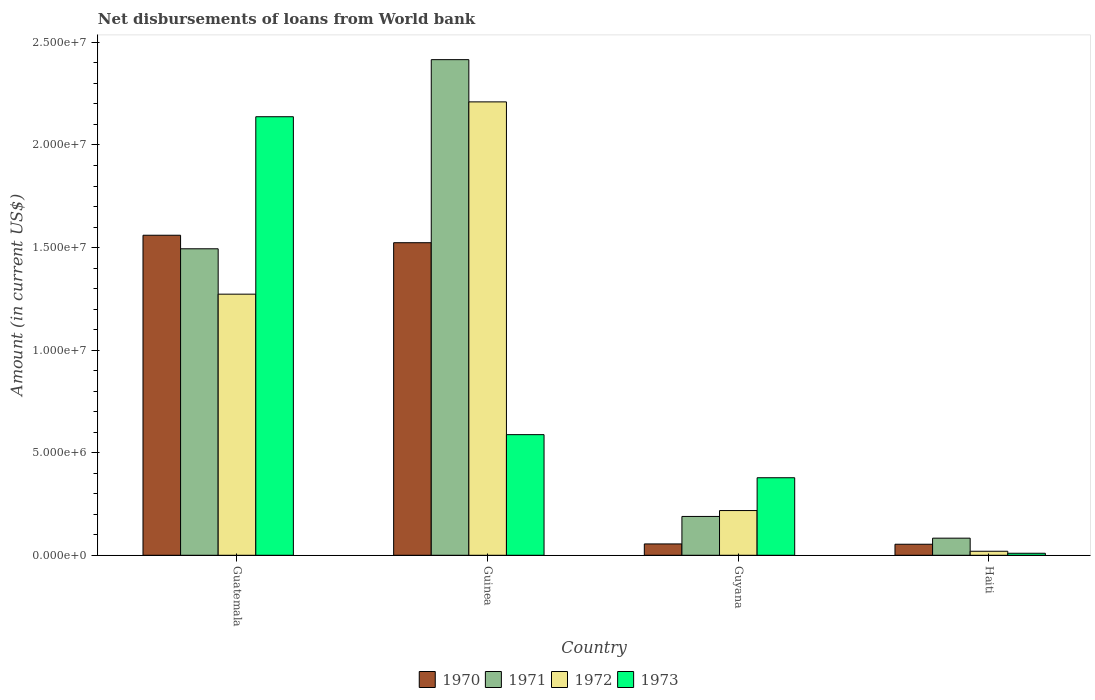Are the number of bars per tick equal to the number of legend labels?
Give a very brief answer. Yes. How many bars are there on the 2nd tick from the left?
Provide a short and direct response. 4. How many bars are there on the 2nd tick from the right?
Ensure brevity in your answer.  4. What is the label of the 2nd group of bars from the left?
Offer a very short reply. Guinea. What is the amount of loan disbursed from World Bank in 1973 in Guinea?
Provide a short and direct response. 5.88e+06. Across all countries, what is the maximum amount of loan disbursed from World Bank in 1970?
Your answer should be very brief. 1.56e+07. Across all countries, what is the minimum amount of loan disbursed from World Bank in 1970?
Give a very brief answer. 5.38e+05. In which country was the amount of loan disbursed from World Bank in 1973 maximum?
Keep it short and to the point. Guatemala. In which country was the amount of loan disbursed from World Bank in 1973 minimum?
Your answer should be very brief. Haiti. What is the total amount of loan disbursed from World Bank in 1970 in the graph?
Your response must be concise. 3.19e+07. What is the difference between the amount of loan disbursed from World Bank in 1972 in Guinea and that in Haiti?
Keep it short and to the point. 2.19e+07. What is the difference between the amount of loan disbursed from World Bank in 1971 in Guatemala and the amount of loan disbursed from World Bank in 1972 in Guyana?
Ensure brevity in your answer.  1.28e+07. What is the average amount of loan disbursed from World Bank in 1973 per country?
Offer a very short reply. 7.78e+06. What is the difference between the amount of loan disbursed from World Bank of/in 1971 and amount of loan disbursed from World Bank of/in 1972 in Guyana?
Offer a very short reply. -2.87e+05. In how many countries, is the amount of loan disbursed from World Bank in 1971 greater than 20000000 US$?
Your answer should be compact. 1. What is the ratio of the amount of loan disbursed from World Bank in 1973 in Guyana to that in Haiti?
Give a very brief answer. 38.56. Is the difference between the amount of loan disbursed from World Bank in 1971 in Guyana and Haiti greater than the difference between the amount of loan disbursed from World Bank in 1972 in Guyana and Haiti?
Your response must be concise. No. What is the difference between the highest and the second highest amount of loan disbursed from World Bank in 1973?
Your answer should be compact. 1.76e+07. What is the difference between the highest and the lowest amount of loan disbursed from World Bank in 1972?
Your answer should be compact. 2.19e+07. Is it the case that in every country, the sum of the amount of loan disbursed from World Bank in 1973 and amount of loan disbursed from World Bank in 1970 is greater than the sum of amount of loan disbursed from World Bank in 1972 and amount of loan disbursed from World Bank in 1971?
Your answer should be very brief. No. What does the 4th bar from the left in Haiti represents?
Ensure brevity in your answer.  1973. Is it the case that in every country, the sum of the amount of loan disbursed from World Bank in 1972 and amount of loan disbursed from World Bank in 1971 is greater than the amount of loan disbursed from World Bank in 1973?
Provide a short and direct response. Yes. How many bars are there?
Offer a very short reply. 16. What is the difference between two consecutive major ticks on the Y-axis?
Offer a very short reply. 5.00e+06. Are the values on the major ticks of Y-axis written in scientific E-notation?
Ensure brevity in your answer.  Yes. Does the graph contain any zero values?
Your response must be concise. No. Where does the legend appear in the graph?
Make the answer very short. Bottom center. What is the title of the graph?
Give a very brief answer. Net disbursements of loans from World bank. Does "1978" appear as one of the legend labels in the graph?
Ensure brevity in your answer.  No. What is the label or title of the X-axis?
Your answer should be compact. Country. What is the label or title of the Y-axis?
Provide a succinct answer. Amount (in current US$). What is the Amount (in current US$) of 1970 in Guatemala?
Offer a terse response. 1.56e+07. What is the Amount (in current US$) of 1971 in Guatemala?
Ensure brevity in your answer.  1.49e+07. What is the Amount (in current US$) of 1972 in Guatemala?
Your response must be concise. 1.27e+07. What is the Amount (in current US$) in 1973 in Guatemala?
Offer a terse response. 2.14e+07. What is the Amount (in current US$) in 1970 in Guinea?
Provide a short and direct response. 1.52e+07. What is the Amount (in current US$) of 1971 in Guinea?
Your response must be concise. 2.42e+07. What is the Amount (in current US$) in 1972 in Guinea?
Provide a succinct answer. 2.21e+07. What is the Amount (in current US$) in 1973 in Guinea?
Keep it short and to the point. 5.88e+06. What is the Amount (in current US$) in 1970 in Guyana?
Make the answer very short. 5.53e+05. What is the Amount (in current US$) in 1971 in Guyana?
Your answer should be compact. 1.89e+06. What is the Amount (in current US$) in 1972 in Guyana?
Provide a succinct answer. 2.18e+06. What is the Amount (in current US$) in 1973 in Guyana?
Make the answer very short. 3.78e+06. What is the Amount (in current US$) of 1970 in Haiti?
Provide a short and direct response. 5.38e+05. What is the Amount (in current US$) of 1971 in Haiti?
Ensure brevity in your answer.  8.34e+05. What is the Amount (in current US$) in 1972 in Haiti?
Your response must be concise. 1.96e+05. What is the Amount (in current US$) of 1973 in Haiti?
Ensure brevity in your answer.  9.80e+04. Across all countries, what is the maximum Amount (in current US$) of 1970?
Provide a succinct answer. 1.56e+07. Across all countries, what is the maximum Amount (in current US$) of 1971?
Keep it short and to the point. 2.42e+07. Across all countries, what is the maximum Amount (in current US$) in 1972?
Offer a terse response. 2.21e+07. Across all countries, what is the maximum Amount (in current US$) in 1973?
Provide a short and direct response. 2.14e+07. Across all countries, what is the minimum Amount (in current US$) of 1970?
Ensure brevity in your answer.  5.38e+05. Across all countries, what is the minimum Amount (in current US$) in 1971?
Give a very brief answer. 8.34e+05. Across all countries, what is the minimum Amount (in current US$) in 1972?
Ensure brevity in your answer.  1.96e+05. Across all countries, what is the minimum Amount (in current US$) of 1973?
Provide a succinct answer. 9.80e+04. What is the total Amount (in current US$) in 1970 in the graph?
Provide a short and direct response. 3.19e+07. What is the total Amount (in current US$) in 1971 in the graph?
Offer a very short reply. 4.18e+07. What is the total Amount (in current US$) in 1972 in the graph?
Your answer should be very brief. 3.72e+07. What is the total Amount (in current US$) of 1973 in the graph?
Make the answer very short. 3.11e+07. What is the difference between the Amount (in current US$) of 1970 in Guatemala and that in Guinea?
Ensure brevity in your answer.  3.64e+05. What is the difference between the Amount (in current US$) of 1971 in Guatemala and that in Guinea?
Ensure brevity in your answer.  -9.22e+06. What is the difference between the Amount (in current US$) of 1972 in Guatemala and that in Guinea?
Ensure brevity in your answer.  -9.37e+06. What is the difference between the Amount (in current US$) of 1973 in Guatemala and that in Guinea?
Provide a short and direct response. 1.55e+07. What is the difference between the Amount (in current US$) of 1970 in Guatemala and that in Guyana?
Provide a succinct answer. 1.50e+07. What is the difference between the Amount (in current US$) of 1971 in Guatemala and that in Guyana?
Offer a terse response. 1.30e+07. What is the difference between the Amount (in current US$) in 1972 in Guatemala and that in Guyana?
Your answer should be very brief. 1.05e+07. What is the difference between the Amount (in current US$) in 1973 in Guatemala and that in Guyana?
Make the answer very short. 1.76e+07. What is the difference between the Amount (in current US$) of 1970 in Guatemala and that in Haiti?
Your answer should be very brief. 1.51e+07. What is the difference between the Amount (in current US$) of 1971 in Guatemala and that in Haiti?
Offer a terse response. 1.41e+07. What is the difference between the Amount (in current US$) of 1972 in Guatemala and that in Haiti?
Keep it short and to the point. 1.25e+07. What is the difference between the Amount (in current US$) of 1973 in Guatemala and that in Haiti?
Offer a very short reply. 2.13e+07. What is the difference between the Amount (in current US$) in 1970 in Guinea and that in Guyana?
Your answer should be compact. 1.47e+07. What is the difference between the Amount (in current US$) of 1971 in Guinea and that in Guyana?
Your answer should be very brief. 2.23e+07. What is the difference between the Amount (in current US$) in 1972 in Guinea and that in Guyana?
Your answer should be very brief. 1.99e+07. What is the difference between the Amount (in current US$) of 1973 in Guinea and that in Guyana?
Your response must be concise. 2.10e+06. What is the difference between the Amount (in current US$) of 1970 in Guinea and that in Haiti?
Offer a very short reply. 1.47e+07. What is the difference between the Amount (in current US$) in 1971 in Guinea and that in Haiti?
Your answer should be very brief. 2.33e+07. What is the difference between the Amount (in current US$) of 1972 in Guinea and that in Haiti?
Ensure brevity in your answer.  2.19e+07. What is the difference between the Amount (in current US$) of 1973 in Guinea and that in Haiti?
Ensure brevity in your answer.  5.78e+06. What is the difference between the Amount (in current US$) of 1970 in Guyana and that in Haiti?
Provide a succinct answer. 1.50e+04. What is the difference between the Amount (in current US$) of 1971 in Guyana and that in Haiti?
Provide a succinct answer. 1.06e+06. What is the difference between the Amount (in current US$) in 1972 in Guyana and that in Haiti?
Offer a very short reply. 1.98e+06. What is the difference between the Amount (in current US$) in 1973 in Guyana and that in Haiti?
Ensure brevity in your answer.  3.68e+06. What is the difference between the Amount (in current US$) of 1970 in Guatemala and the Amount (in current US$) of 1971 in Guinea?
Ensure brevity in your answer.  -8.56e+06. What is the difference between the Amount (in current US$) in 1970 in Guatemala and the Amount (in current US$) in 1972 in Guinea?
Offer a very short reply. -6.50e+06. What is the difference between the Amount (in current US$) in 1970 in Guatemala and the Amount (in current US$) in 1973 in Guinea?
Your response must be concise. 9.72e+06. What is the difference between the Amount (in current US$) in 1971 in Guatemala and the Amount (in current US$) in 1972 in Guinea?
Keep it short and to the point. -7.16e+06. What is the difference between the Amount (in current US$) in 1971 in Guatemala and the Amount (in current US$) in 1973 in Guinea?
Offer a very short reply. 9.06e+06. What is the difference between the Amount (in current US$) of 1972 in Guatemala and the Amount (in current US$) of 1973 in Guinea?
Offer a terse response. 6.85e+06. What is the difference between the Amount (in current US$) in 1970 in Guatemala and the Amount (in current US$) in 1971 in Guyana?
Keep it short and to the point. 1.37e+07. What is the difference between the Amount (in current US$) of 1970 in Guatemala and the Amount (in current US$) of 1972 in Guyana?
Your answer should be very brief. 1.34e+07. What is the difference between the Amount (in current US$) in 1970 in Guatemala and the Amount (in current US$) in 1973 in Guyana?
Your answer should be very brief. 1.18e+07. What is the difference between the Amount (in current US$) of 1971 in Guatemala and the Amount (in current US$) of 1972 in Guyana?
Make the answer very short. 1.28e+07. What is the difference between the Amount (in current US$) of 1971 in Guatemala and the Amount (in current US$) of 1973 in Guyana?
Give a very brief answer. 1.12e+07. What is the difference between the Amount (in current US$) in 1972 in Guatemala and the Amount (in current US$) in 1973 in Guyana?
Provide a succinct answer. 8.95e+06. What is the difference between the Amount (in current US$) of 1970 in Guatemala and the Amount (in current US$) of 1971 in Haiti?
Give a very brief answer. 1.48e+07. What is the difference between the Amount (in current US$) of 1970 in Guatemala and the Amount (in current US$) of 1972 in Haiti?
Ensure brevity in your answer.  1.54e+07. What is the difference between the Amount (in current US$) in 1970 in Guatemala and the Amount (in current US$) in 1973 in Haiti?
Your response must be concise. 1.55e+07. What is the difference between the Amount (in current US$) in 1971 in Guatemala and the Amount (in current US$) in 1972 in Haiti?
Give a very brief answer. 1.47e+07. What is the difference between the Amount (in current US$) of 1971 in Guatemala and the Amount (in current US$) of 1973 in Haiti?
Provide a succinct answer. 1.48e+07. What is the difference between the Amount (in current US$) of 1972 in Guatemala and the Amount (in current US$) of 1973 in Haiti?
Your answer should be very brief. 1.26e+07. What is the difference between the Amount (in current US$) in 1970 in Guinea and the Amount (in current US$) in 1971 in Guyana?
Provide a short and direct response. 1.33e+07. What is the difference between the Amount (in current US$) in 1970 in Guinea and the Amount (in current US$) in 1972 in Guyana?
Keep it short and to the point. 1.31e+07. What is the difference between the Amount (in current US$) of 1970 in Guinea and the Amount (in current US$) of 1973 in Guyana?
Make the answer very short. 1.15e+07. What is the difference between the Amount (in current US$) of 1971 in Guinea and the Amount (in current US$) of 1972 in Guyana?
Your answer should be very brief. 2.20e+07. What is the difference between the Amount (in current US$) of 1971 in Guinea and the Amount (in current US$) of 1973 in Guyana?
Offer a terse response. 2.04e+07. What is the difference between the Amount (in current US$) in 1972 in Guinea and the Amount (in current US$) in 1973 in Guyana?
Give a very brief answer. 1.83e+07. What is the difference between the Amount (in current US$) of 1970 in Guinea and the Amount (in current US$) of 1971 in Haiti?
Offer a very short reply. 1.44e+07. What is the difference between the Amount (in current US$) in 1970 in Guinea and the Amount (in current US$) in 1972 in Haiti?
Offer a very short reply. 1.50e+07. What is the difference between the Amount (in current US$) of 1970 in Guinea and the Amount (in current US$) of 1973 in Haiti?
Ensure brevity in your answer.  1.51e+07. What is the difference between the Amount (in current US$) in 1971 in Guinea and the Amount (in current US$) in 1972 in Haiti?
Give a very brief answer. 2.40e+07. What is the difference between the Amount (in current US$) of 1971 in Guinea and the Amount (in current US$) of 1973 in Haiti?
Provide a succinct answer. 2.41e+07. What is the difference between the Amount (in current US$) in 1972 in Guinea and the Amount (in current US$) in 1973 in Haiti?
Your answer should be compact. 2.20e+07. What is the difference between the Amount (in current US$) in 1970 in Guyana and the Amount (in current US$) in 1971 in Haiti?
Give a very brief answer. -2.81e+05. What is the difference between the Amount (in current US$) in 1970 in Guyana and the Amount (in current US$) in 1972 in Haiti?
Offer a very short reply. 3.57e+05. What is the difference between the Amount (in current US$) of 1970 in Guyana and the Amount (in current US$) of 1973 in Haiti?
Offer a terse response. 4.55e+05. What is the difference between the Amount (in current US$) of 1971 in Guyana and the Amount (in current US$) of 1972 in Haiti?
Your response must be concise. 1.70e+06. What is the difference between the Amount (in current US$) of 1971 in Guyana and the Amount (in current US$) of 1973 in Haiti?
Give a very brief answer. 1.80e+06. What is the difference between the Amount (in current US$) in 1972 in Guyana and the Amount (in current US$) in 1973 in Haiti?
Your answer should be compact. 2.08e+06. What is the average Amount (in current US$) in 1970 per country?
Offer a terse response. 7.98e+06. What is the average Amount (in current US$) of 1971 per country?
Your answer should be compact. 1.05e+07. What is the average Amount (in current US$) in 1972 per country?
Offer a very short reply. 9.30e+06. What is the average Amount (in current US$) of 1973 per country?
Your answer should be very brief. 7.78e+06. What is the difference between the Amount (in current US$) in 1970 and Amount (in current US$) in 1971 in Guatemala?
Offer a terse response. 6.60e+05. What is the difference between the Amount (in current US$) in 1970 and Amount (in current US$) in 1972 in Guatemala?
Your response must be concise. 2.87e+06. What is the difference between the Amount (in current US$) of 1970 and Amount (in current US$) of 1973 in Guatemala?
Make the answer very short. -5.78e+06. What is the difference between the Amount (in current US$) of 1971 and Amount (in current US$) of 1972 in Guatemala?
Your answer should be compact. 2.21e+06. What is the difference between the Amount (in current US$) in 1971 and Amount (in current US$) in 1973 in Guatemala?
Your response must be concise. -6.44e+06. What is the difference between the Amount (in current US$) of 1972 and Amount (in current US$) of 1973 in Guatemala?
Provide a short and direct response. -8.65e+06. What is the difference between the Amount (in current US$) in 1970 and Amount (in current US$) in 1971 in Guinea?
Give a very brief answer. -8.92e+06. What is the difference between the Amount (in current US$) of 1970 and Amount (in current US$) of 1972 in Guinea?
Offer a terse response. -6.86e+06. What is the difference between the Amount (in current US$) of 1970 and Amount (in current US$) of 1973 in Guinea?
Your answer should be compact. 9.36e+06. What is the difference between the Amount (in current US$) in 1971 and Amount (in current US$) in 1972 in Guinea?
Keep it short and to the point. 2.06e+06. What is the difference between the Amount (in current US$) of 1971 and Amount (in current US$) of 1973 in Guinea?
Ensure brevity in your answer.  1.83e+07. What is the difference between the Amount (in current US$) of 1972 and Amount (in current US$) of 1973 in Guinea?
Offer a terse response. 1.62e+07. What is the difference between the Amount (in current US$) of 1970 and Amount (in current US$) of 1971 in Guyana?
Provide a short and direct response. -1.34e+06. What is the difference between the Amount (in current US$) in 1970 and Amount (in current US$) in 1972 in Guyana?
Your answer should be compact. -1.63e+06. What is the difference between the Amount (in current US$) of 1970 and Amount (in current US$) of 1973 in Guyana?
Keep it short and to the point. -3.23e+06. What is the difference between the Amount (in current US$) in 1971 and Amount (in current US$) in 1972 in Guyana?
Provide a short and direct response. -2.87e+05. What is the difference between the Amount (in current US$) in 1971 and Amount (in current US$) in 1973 in Guyana?
Make the answer very short. -1.89e+06. What is the difference between the Amount (in current US$) in 1972 and Amount (in current US$) in 1973 in Guyana?
Provide a succinct answer. -1.60e+06. What is the difference between the Amount (in current US$) of 1970 and Amount (in current US$) of 1971 in Haiti?
Make the answer very short. -2.96e+05. What is the difference between the Amount (in current US$) of 1970 and Amount (in current US$) of 1972 in Haiti?
Offer a terse response. 3.42e+05. What is the difference between the Amount (in current US$) in 1970 and Amount (in current US$) in 1973 in Haiti?
Make the answer very short. 4.40e+05. What is the difference between the Amount (in current US$) of 1971 and Amount (in current US$) of 1972 in Haiti?
Provide a short and direct response. 6.38e+05. What is the difference between the Amount (in current US$) in 1971 and Amount (in current US$) in 1973 in Haiti?
Give a very brief answer. 7.36e+05. What is the difference between the Amount (in current US$) of 1972 and Amount (in current US$) of 1973 in Haiti?
Your answer should be compact. 9.80e+04. What is the ratio of the Amount (in current US$) in 1970 in Guatemala to that in Guinea?
Keep it short and to the point. 1.02. What is the ratio of the Amount (in current US$) of 1971 in Guatemala to that in Guinea?
Keep it short and to the point. 0.62. What is the ratio of the Amount (in current US$) in 1972 in Guatemala to that in Guinea?
Offer a terse response. 0.58. What is the ratio of the Amount (in current US$) in 1973 in Guatemala to that in Guinea?
Keep it short and to the point. 3.64. What is the ratio of the Amount (in current US$) of 1970 in Guatemala to that in Guyana?
Offer a terse response. 28.21. What is the ratio of the Amount (in current US$) of 1971 in Guatemala to that in Guyana?
Your answer should be very brief. 7.89. What is the ratio of the Amount (in current US$) in 1972 in Guatemala to that in Guyana?
Your answer should be compact. 5.84. What is the ratio of the Amount (in current US$) of 1973 in Guatemala to that in Guyana?
Your response must be concise. 5.66. What is the ratio of the Amount (in current US$) in 1970 in Guatemala to that in Haiti?
Provide a succinct answer. 29. What is the ratio of the Amount (in current US$) of 1971 in Guatemala to that in Haiti?
Offer a terse response. 17.91. What is the ratio of the Amount (in current US$) of 1972 in Guatemala to that in Haiti?
Provide a succinct answer. 64.94. What is the ratio of the Amount (in current US$) in 1973 in Guatemala to that in Haiti?
Your answer should be compact. 218.13. What is the ratio of the Amount (in current US$) of 1970 in Guinea to that in Guyana?
Your answer should be very brief. 27.55. What is the ratio of the Amount (in current US$) in 1971 in Guinea to that in Guyana?
Ensure brevity in your answer.  12.76. What is the ratio of the Amount (in current US$) of 1972 in Guinea to that in Guyana?
Offer a terse response. 10.14. What is the ratio of the Amount (in current US$) of 1973 in Guinea to that in Guyana?
Give a very brief answer. 1.56. What is the ratio of the Amount (in current US$) of 1970 in Guinea to that in Haiti?
Your answer should be very brief. 28.32. What is the ratio of the Amount (in current US$) in 1971 in Guinea to that in Haiti?
Give a very brief answer. 28.97. What is the ratio of the Amount (in current US$) in 1972 in Guinea to that in Haiti?
Provide a succinct answer. 112.76. What is the ratio of the Amount (in current US$) in 1973 in Guinea to that in Haiti?
Your answer should be compact. 60. What is the ratio of the Amount (in current US$) in 1970 in Guyana to that in Haiti?
Your answer should be compact. 1.03. What is the ratio of the Amount (in current US$) of 1971 in Guyana to that in Haiti?
Your answer should be compact. 2.27. What is the ratio of the Amount (in current US$) in 1972 in Guyana to that in Haiti?
Give a very brief answer. 11.12. What is the ratio of the Amount (in current US$) of 1973 in Guyana to that in Haiti?
Provide a short and direct response. 38.56. What is the difference between the highest and the second highest Amount (in current US$) of 1970?
Give a very brief answer. 3.64e+05. What is the difference between the highest and the second highest Amount (in current US$) of 1971?
Provide a short and direct response. 9.22e+06. What is the difference between the highest and the second highest Amount (in current US$) of 1972?
Ensure brevity in your answer.  9.37e+06. What is the difference between the highest and the second highest Amount (in current US$) in 1973?
Offer a terse response. 1.55e+07. What is the difference between the highest and the lowest Amount (in current US$) of 1970?
Make the answer very short. 1.51e+07. What is the difference between the highest and the lowest Amount (in current US$) in 1971?
Offer a very short reply. 2.33e+07. What is the difference between the highest and the lowest Amount (in current US$) in 1972?
Provide a succinct answer. 2.19e+07. What is the difference between the highest and the lowest Amount (in current US$) of 1973?
Make the answer very short. 2.13e+07. 